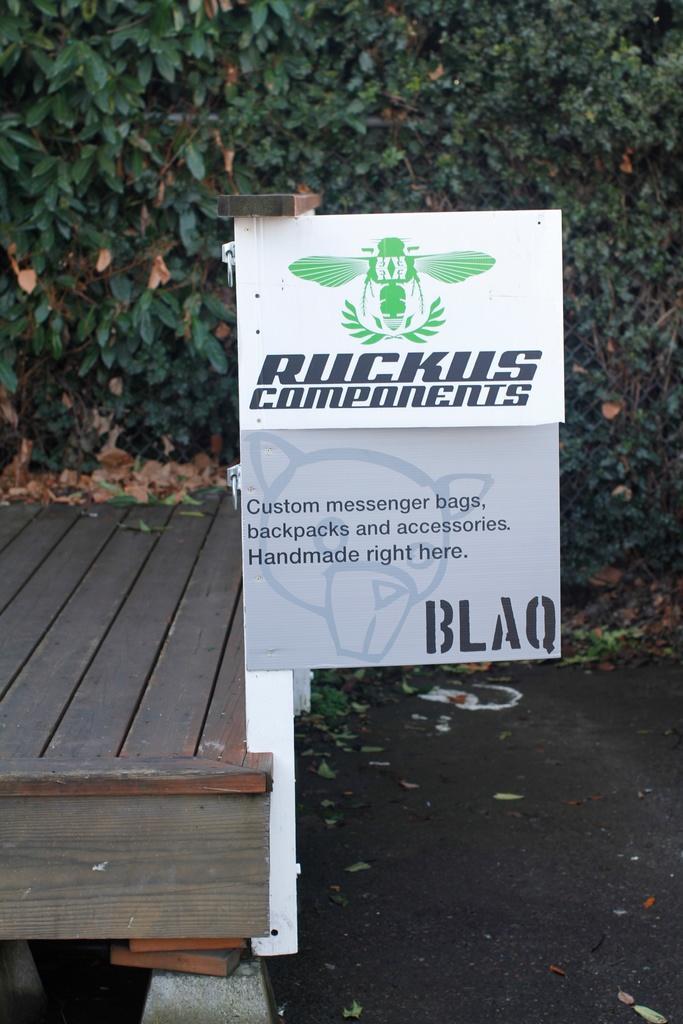Please provide a concise description of this image. In the picture there is a wooden plank, there is a pole with the boards, on the boards we can see some text, there may be trees and there are dried leaves on the ground. 